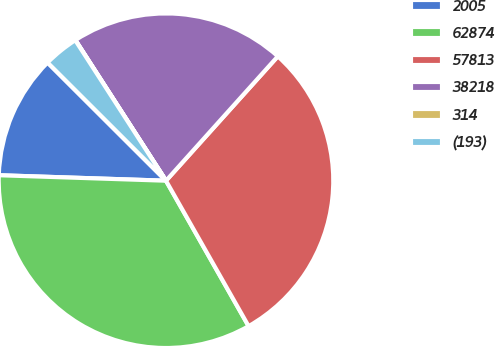<chart> <loc_0><loc_0><loc_500><loc_500><pie_chart><fcel>2005<fcel>62874<fcel>57813<fcel>38218<fcel>314<fcel>(193)<nl><fcel>11.96%<fcel>33.74%<fcel>30.12%<fcel>20.76%<fcel>0.02%<fcel>3.39%<nl></chart> 